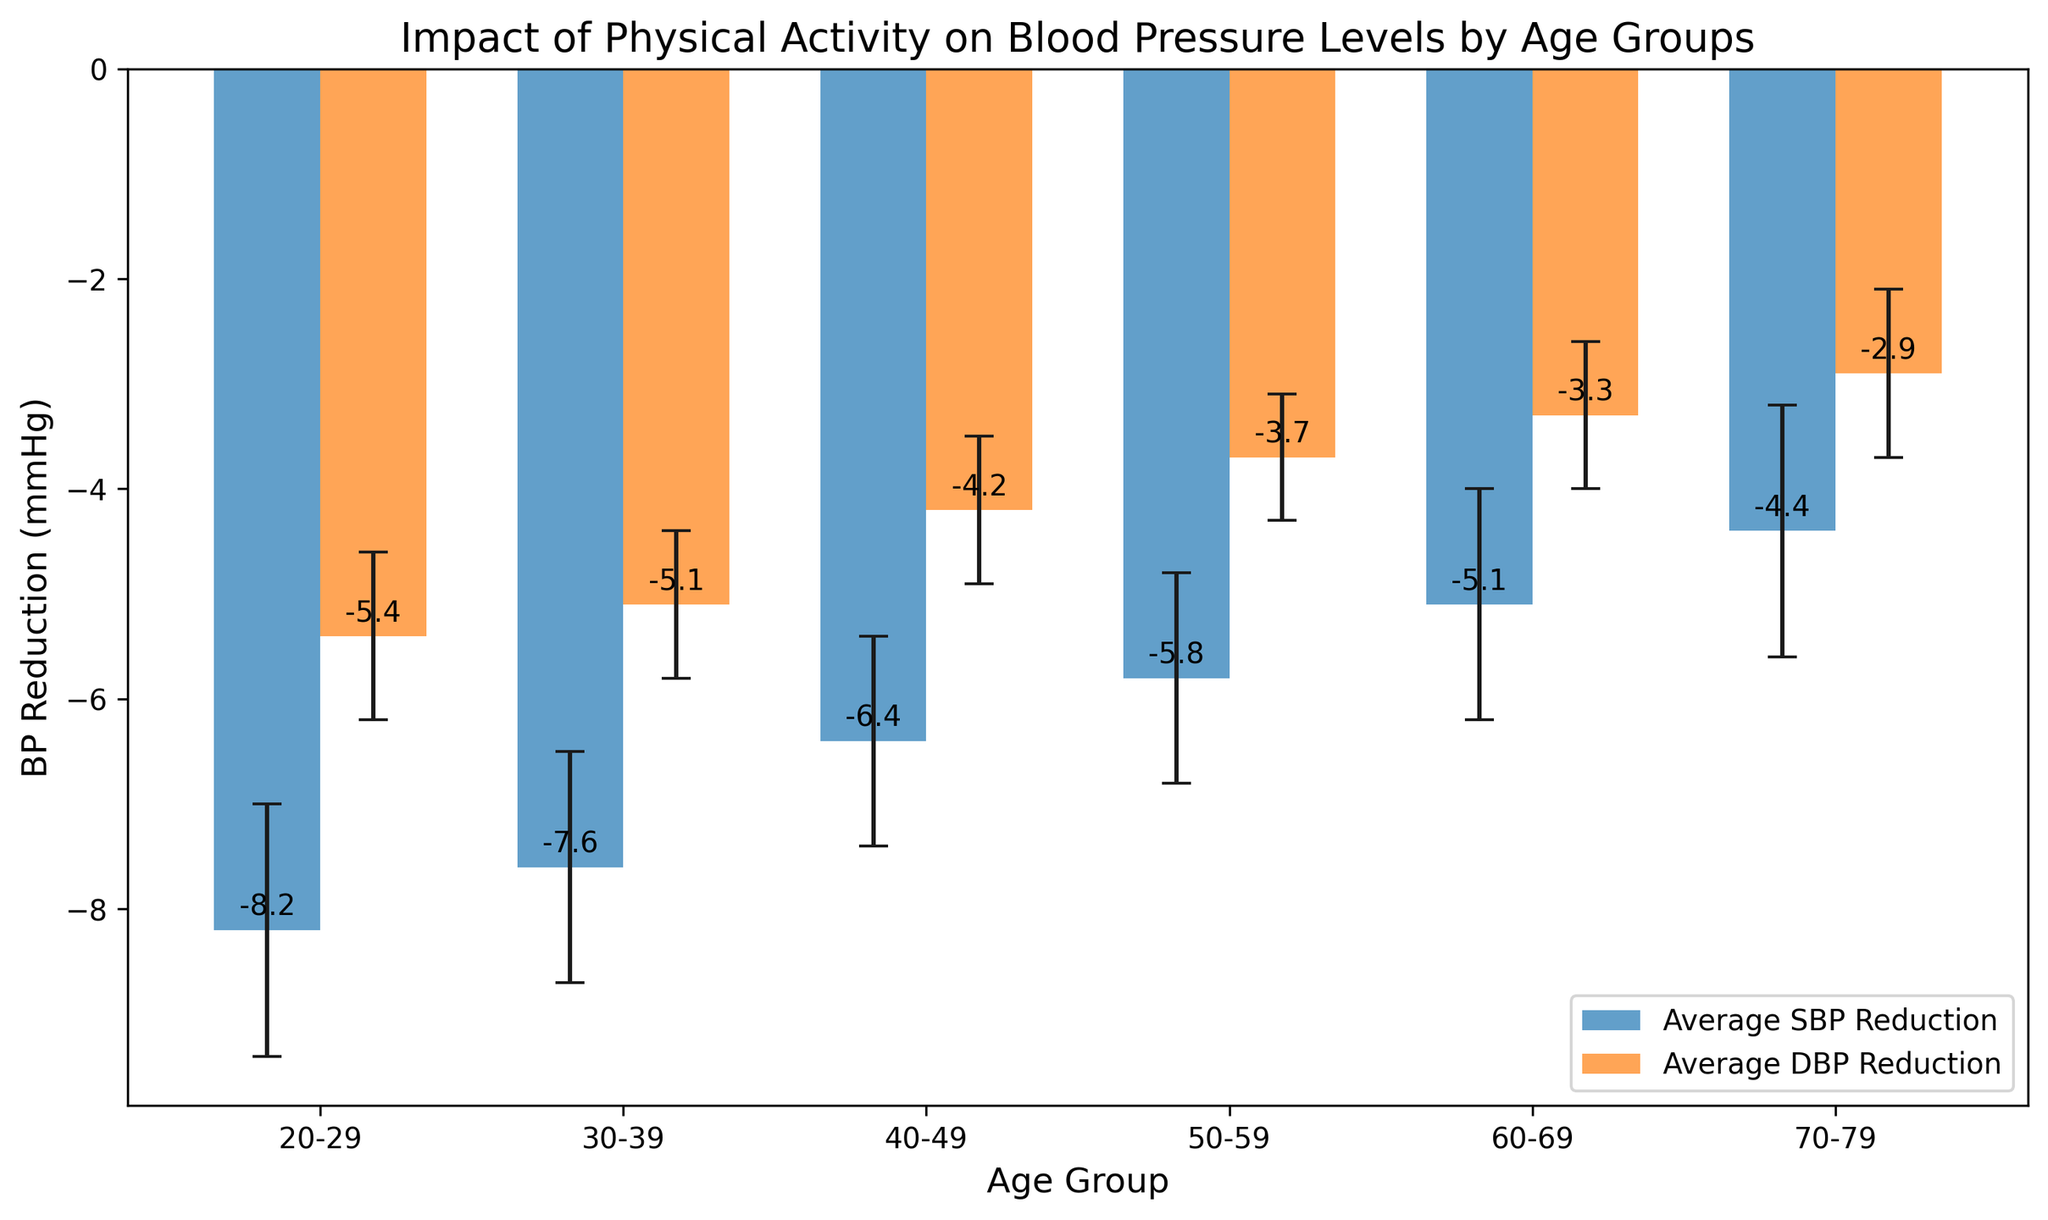What is the average SBP reduction for the 30-39 age group? Look at the bar corresponding to the 30-39 age group and find the height labeled for the SBP reduction.
Answer: -7.6 mmHg Which age group shows the smallest reduction in DBP due to physical activity? Compare the heights of the DBP reduction bars across all age groups and find the smallest one.
Answer: 70-79 Which age group has the highest reduction in SBP? Compare the heights of the SBP reduction bars across all age groups and find the highest one.
Answer: 20-29 What are the standard errors for the SBP and DBP reductions in the 60-69 age group? Find the error bars’ lengths for both SBP and DBP reductions in the 60-69 age group.
Answer: 1.1 (SBP), 0.7 (DBP) How does the DBP reduction for the 30-39 age group compare to that of the 70-79 age group? Compare the heights of the DBP reduction bars for the 30-39 and 70-79 age groups.
Answer: 30-39 has a greater reduction Among all age groups, which has the smallest standard error for DBP reduction? Compare the lengths of the error bars for DBP reductions across all age groups and find the smallest one.
Answer: 50-59 What are the average BP reductions (SBP and DBP) for the 50-59 age group? Find the heights labeled for both SBP and DBP reductions for the 50-59 age group.
Answer: -5.8 mmHg (SBP), -3.7 mmHg (DBP) 